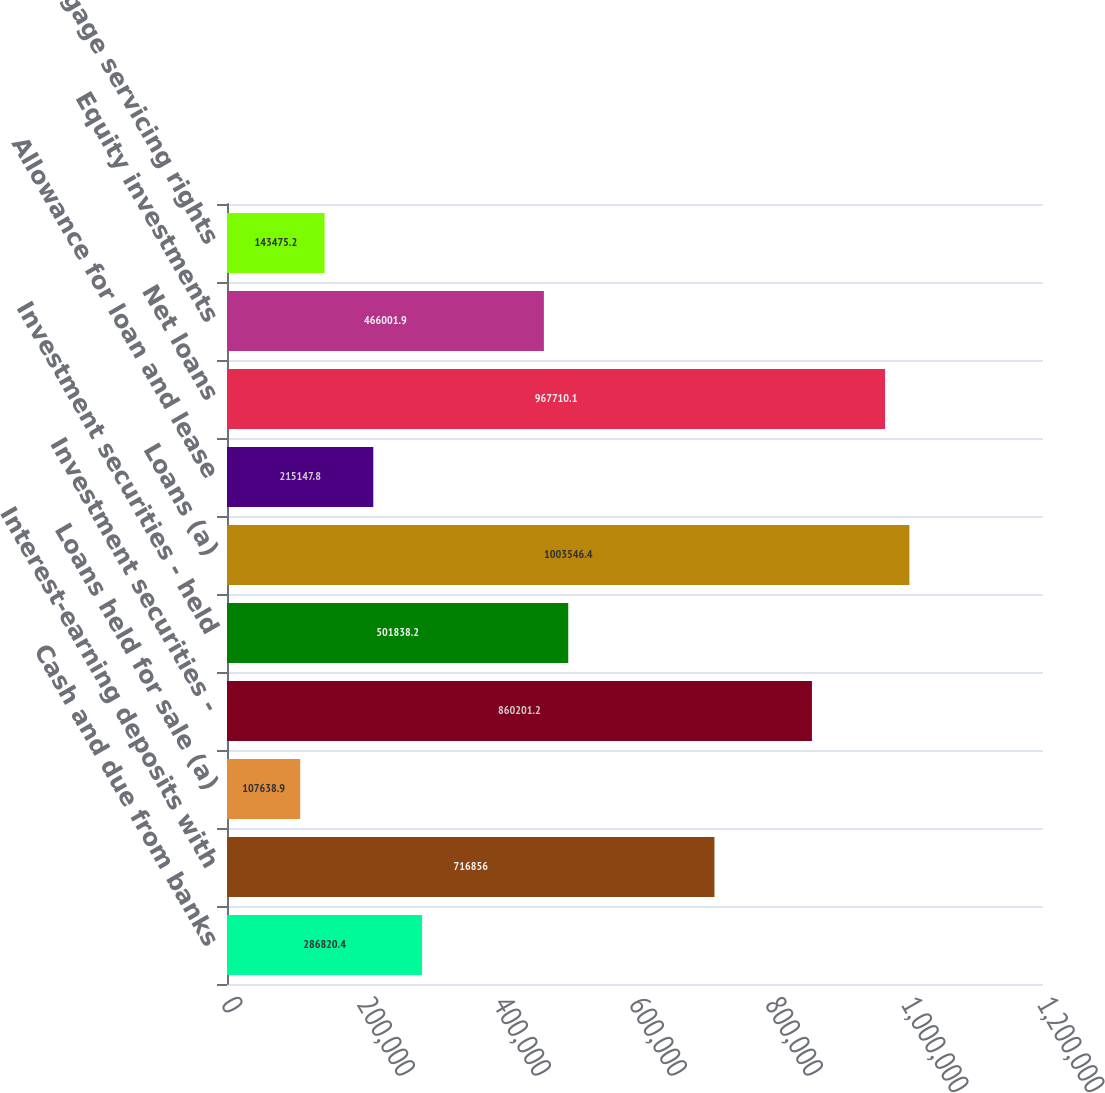Convert chart to OTSL. <chart><loc_0><loc_0><loc_500><loc_500><bar_chart><fcel>Cash and due from banks<fcel>Interest-earning deposits with<fcel>Loans held for sale (a)<fcel>Investment securities -<fcel>Investment securities - held<fcel>Loans (a)<fcel>Allowance for loan and lease<fcel>Net loans<fcel>Equity investments<fcel>Mortgage servicing rights<nl><fcel>286820<fcel>716856<fcel>107639<fcel>860201<fcel>501838<fcel>1.00355e+06<fcel>215148<fcel>967710<fcel>466002<fcel>143475<nl></chart> 